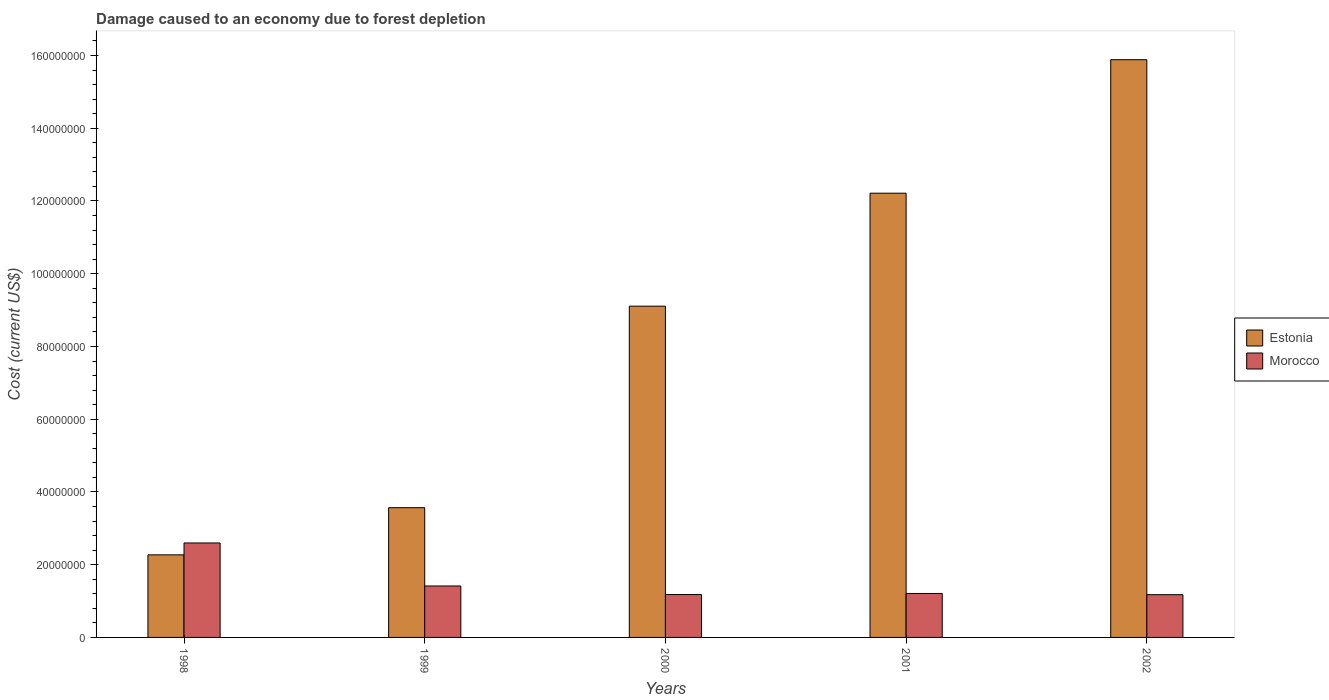How many groups of bars are there?
Provide a succinct answer. 5. Are the number of bars on each tick of the X-axis equal?
Give a very brief answer. Yes. How many bars are there on the 2nd tick from the right?
Ensure brevity in your answer.  2. What is the label of the 5th group of bars from the left?
Provide a succinct answer. 2002. What is the cost of damage caused due to forest depletion in Morocco in 1999?
Provide a short and direct response. 1.41e+07. Across all years, what is the maximum cost of damage caused due to forest depletion in Estonia?
Give a very brief answer. 1.59e+08. Across all years, what is the minimum cost of damage caused due to forest depletion in Estonia?
Your answer should be compact. 2.27e+07. In which year was the cost of damage caused due to forest depletion in Estonia maximum?
Your answer should be very brief. 2002. What is the total cost of damage caused due to forest depletion in Morocco in the graph?
Your answer should be compact. 7.57e+07. What is the difference between the cost of damage caused due to forest depletion in Morocco in 2000 and that in 2002?
Keep it short and to the point. 3.97e+04. What is the difference between the cost of damage caused due to forest depletion in Morocco in 2001 and the cost of damage caused due to forest depletion in Estonia in 1999?
Provide a short and direct response. -2.36e+07. What is the average cost of damage caused due to forest depletion in Morocco per year?
Keep it short and to the point. 1.51e+07. In the year 2002, what is the difference between the cost of damage caused due to forest depletion in Estonia and cost of damage caused due to forest depletion in Morocco?
Ensure brevity in your answer.  1.47e+08. What is the ratio of the cost of damage caused due to forest depletion in Estonia in 1999 to that in 2002?
Provide a succinct answer. 0.22. What is the difference between the highest and the second highest cost of damage caused due to forest depletion in Estonia?
Your answer should be compact. 3.67e+07. What is the difference between the highest and the lowest cost of damage caused due to forest depletion in Morocco?
Give a very brief answer. 1.42e+07. In how many years, is the cost of damage caused due to forest depletion in Morocco greater than the average cost of damage caused due to forest depletion in Morocco taken over all years?
Your answer should be very brief. 1. Is the sum of the cost of damage caused due to forest depletion in Morocco in 2000 and 2002 greater than the maximum cost of damage caused due to forest depletion in Estonia across all years?
Your response must be concise. No. What does the 1st bar from the left in 2001 represents?
Keep it short and to the point. Estonia. What does the 1st bar from the right in 2002 represents?
Provide a short and direct response. Morocco. How many bars are there?
Give a very brief answer. 10. How many years are there in the graph?
Keep it short and to the point. 5. What is the difference between two consecutive major ticks on the Y-axis?
Give a very brief answer. 2.00e+07. Are the values on the major ticks of Y-axis written in scientific E-notation?
Provide a succinct answer. No. Does the graph contain any zero values?
Your response must be concise. No. Where does the legend appear in the graph?
Offer a terse response. Center right. What is the title of the graph?
Provide a succinct answer. Damage caused to an economy due to forest depletion. Does "Uzbekistan" appear as one of the legend labels in the graph?
Your answer should be compact. No. What is the label or title of the Y-axis?
Provide a short and direct response. Cost (current US$). What is the Cost (current US$) in Estonia in 1998?
Your answer should be very brief. 2.27e+07. What is the Cost (current US$) of Morocco in 1998?
Offer a very short reply. 2.60e+07. What is the Cost (current US$) of Estonia in 1999?
Your response must be concise. 3.57e+07. What is the Cost (current US$) in Morocco in 1999?
Give a very brief answer. 1.41e+07. What is the Cost (current US$) of Estonia in 2000?
Provide a short and direct response. 9.11e+07. What is the Cost (current US$) of Morocco in 2000?
Your response must be concise. 1.18e+07. What is the Cost (current US$) of Estonia in 2001?
Ensure brevity in your answer.  1.22e+08. What is the Cost (current US$) of Morocco in 2001?
Make the answer very short. 1.21e+07. What is the Cost (current US$) in Estonia in 2002?
Offer a very short reply. 1.59e+08. What is the Cost (current US$) in Morocco in 2002?
Offer a very short reply. 1.18e+07. Across all years, what is the maximum Cost (current US$) of Estonia?
Keep it short and to the point. 1.59e+08. Across all years, what is the maximum Cost (current US$) in Morocco?
Ensure brevity in your answer.  2.60e+07. Across all years, what is the minimum Cost (current US$) in Estonia?
Give a very brief answer. 2.27e+07. Across all years, what is the minimum Cost (current US$) in Morocco?
Provide a succinct answer. 1.18e+07. What is the total Cost (current US$) in Estonia in the graph?
Your answer should be very brief. 4.30e+08. What is the total Cost (current US$) in Morocco in the graph?
Your answer should be compact. 7.57e+07. What is the difference between the Cost (current US$) in Estonia in 1998 and that in 1999?
Your answer should be compact. -1.30e+07. What is the difference between the Cost (current US$) of Morocco in 1998 and that in 1999?
Provide a succinct answer. 1.18e+07. What is the difference between the Cost (current US$) of Estonia in 1998 and that in 2000?
Your answer should be compact. -6.84e+07. What is the difference between the Cost (current US$) of Morocco in 1998 and that in 2000?
Make the answer very short. 1.42e+07. What is the difference between the Cost (current US$) in Estonia in 1998 and that in 2001?
Offer a very short reply. -9.94e+07. What is the difference between the Cost (current US$) in Morocco in 1998 and that in 2001?
Make the answer very short. 1.39e+07. What is the difference between the Cost (current US$) of Estonia in 1998 and that in 2002?
Provide a succinct answer. -1.36e+08. What is the difference between the Cost (current US$) of Morocco in 1998 and that in 2002?
Ensure brevity in your answer.  1.42e+07. What is the difference between the Cost (current US$) in Estonia in 1999 and that in 2000?
Make the answer very short. -5.54e+07. What is the difference between the Cost (current US$) of Morocco in 1999 and that in 2000?
Offer a very short reply. 2.36e+06. What is the difference between the Cost (current US$) in Estonia in 1999 and that in 2001?
Your answer should be compact. -8.65e+07. What is the difference between the Cost (current US$) of Morocco in 1999 and that in 2001?
Offer a terse response. 2.06e+06. What is the difference between the Cost (current US$) of Estonia in 1999 and that in 2002?
Ensure brevity in your answer.  -1.23e+08. What is the difference between the Cost (current US$) in Morocco in 1999 and that in 2002?
Offer a very short reply. 2.40e+06. What is the difference between the Cost (current US$) in Estonia in 2000 and that in 2001?
Your answer should be very brief. -3.11e+07. What is the difference between the Cost (current US$) of Morocco in 2000 and that in 2001?
Your response must be concise. -2.92e+05. What is the difference between the Cost (current US$) in Estonia in 2000 and that in 2002?
Your answer should be compact. -6.78e+07. What is the difference between the Cost (current US$) of Morocco in 2000 and that in 2002?
Ensure brevity in your answer.  3.97e+04. What is the difference between the Cost (current US$) in Estonia in 2001 and that in 2002?
Provide a succinct answer. -3.67e+07. What is the difference between the Cost (current US$) in Morocco in 2001 and that in 2002?
Give a very brief answer. 3.32e+05. What is the difference between the Cost (current US$) in Estonia in 1998 and the Cost (current US$) in Morocco in 1999?
Provide a short and direct response. 8.56e+06. What is the difference between the Cost (current US$) of Estonia in 1998 and the Cost (current US$) of Morocco in 2000?
Offer a very short reply. 1.09e+07. What is the difference between the Cost (current US$) in Estonia in 1998 and the Cost (current US$) in Morocco in 2001?
Provide a short and direct response. 1.06e+07. What is the difference between the Cost (current US$) of Estonia in 1998 and the Cost (current US$) of Morocco in 2002?
Make the answer very short. 1.10e+07. What is the difference between the Cost (current US$) of Estonia in 1999 and the Cost (current US$) of Morocco in 2000?
Your answer should be very brief. 2.39e+07. What is the difference between the Cost (current US$) of Estonia in 1999 and the Cost (current US$) of Morocco in 2001?
Keep it short and to the point. 2.36e+07. What is the difference between the Cost (current US$) of Estonia in 1999 and the Cost (current US$) of Morocco in 2002?
Make the answer very short. 2.39e+07. What is the difference between the Cost (current US$) in Estonia in 2000 and the Cost (current US$) in Morocco in 2001?
Make the answer very short. 7.90e+07. What is the difference between the Cost (current US$) of Estonia in 2000 and the Cost (current US$) of Morocco in 2002?
Offer a very short reply. 7.93e+07. What is the difference between the Cost (current US$) in Estonia in 2001 and the Cost (current US$) in Morocco in 2002?
Your response must be concise. 1.10e+08. What is the average Cost (current US$) in Estonia per year?
Your answer should be compact. 8.61e+07. What is the average Cost (current US$) of Morocco per year?
Make the answer very short. 1.51e+07. In the year 1998, what is the difference between the Cost (current US$) in Estonia and Cost (current US$) in Morocco?
Offer a very short reply. -3.27e+06. In the year 1999, what is the difference between the Cost (current US$) in Estonia and Cost (current US$) in Morocco?
Give a very brief answer. 2.15e+07. In the year 2000, what is the difference between the Cost (current US$) of Estonia and Cost (current US$) of Morocco?
Your answer should be compact. 7.93e+07. In the year 2001, what is the difference between the Cost (current US$) in Estonia and Cost (current US$) in Morocco?
Offer a terse response. 1.10e+08. In the year 2002, what is the difference between the Cost (current US$) in Estonia and Cost (current US$) in Morocco?
Ensure brevity in your answer.  1.47e+08. What is the ratio of the Cost (current US$) of Estonia in 1998 to that in 1999?
Your answer should be compact. 0.64. What is the ratio of the Cost (current US$) of Morocco in 1998 to that in 1999?
Make the answer very short. 1.84. What is the ratio of the Cost (current US$) in Estonia in 1998 to that in 2000?
Make the answer very short. 0.25. What is the ratio of the Cost (current US$) in Morocco in 1998 to that in 2000?
Offer a terse response. 2.2. What is the ratio of the Cost (current US$) in Estonia in 1998 to that in 2001?
Offer a very short reply. 0.19. What is the ratio of the Cost (current US$) in Morocco in 1998 to that in 2001?
Make the answer very short. 2.15. What is the ratio of the Cost (current US$) in Estonia in 1998 to that in 2002?
Your answer should be compact. 0.14. What is the ratio of the Cost (current US$) in Morocco in 1998 to that in 2002?
Your answer should be very brief. 2.21. What is the ratio of the Cost (current US$) in Estonia in 1999 to that in 2000?
Your response must be concise. 0.39. What is the ratio of the Cost (current US$) in Morocco in 1999 to that in 2000?
Make the answer very short. 1.2. What is the ratio of the Cost (current US$) in Estonia in 1999 to that in 2001?
Ensure brevity in your answer.  0.29. What is the ratio of the Cost (current US$) in Morocco in 1999 to that in 2001?
Your answer should be compact. 1.17. What is the ratio of the Cost (current US$) in Estonia in 1999 to that in 2002?
Provide a succinct answer. 0.22. What is the ratio of the Cost (current US$) in Morocco in 1999 to that in 2002?
Provide a succinct answer. 1.2. What is the ratio of the Cost (current US$) in Estonia in 2000 to that in 2001?
Your response must be concise. 0.75. What is the ratio of the Cost (current US$) in Morocco in 2000 to that in 2001?
Provide a succinct answer. 0.98. What is the ratio of the Cost (current US$) of Estonia in 2000 to that in 2002?
Offer a terse response. 0.57. What is the ratio of the Cost (current US$) in Morocco in 2000 to that in 2002?
Offer a terse response. 1. What is the ratio of the Cost (current US$) in Estonia in 2001 to that in 2002?
Provide a succinct answer. 0.77. What is the ratio of the Cost (current US$) in Morocco in 2001 to that in 2002?
Provide a succinct answer. 1.03. What is the difference between the highest and the second highest Cost (current US$) in Estonia?
Offer a very short reply. 3.67e+07. What is the difference between the highest and the second highest Cost (current US$) in Morocco?
Provide a short and direct response. 1.18e+07. What is the difference between the highest and the lowest Cost (current US$) in Estonia?
Keep it short and to the point. 1.36e+08. What is the difference between the highest and the lowest Cost (current US$) of Morocco?
Keep it short and to the point. 1.42e+07. 